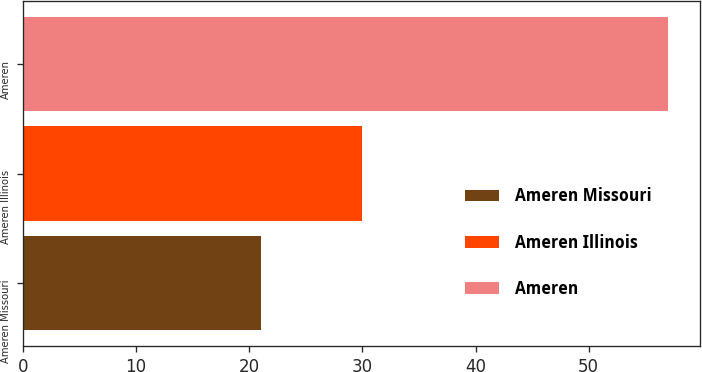<chart> <loc_0><loc_0><loc_500><loc_500><bar_chart><fcel>Ameren Missouri<fcel>Ameren Illinois<fcel>Ameren<nl><fcel>21<fcel>30<fcel>57<nl></chart> 